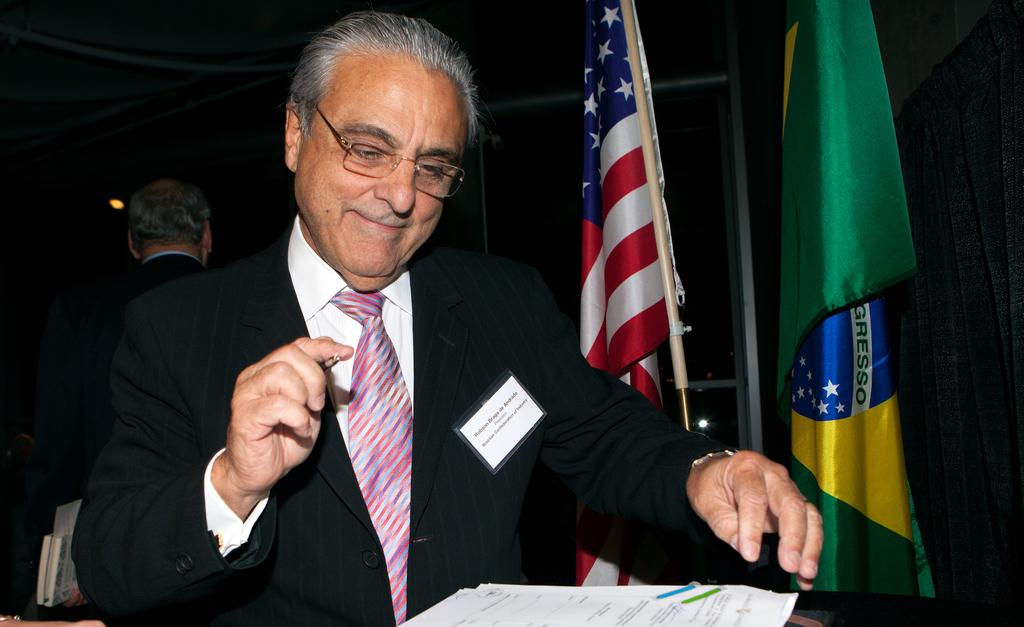What is the person in the foreground of the image doing? The person is holding a pen. What might the person be using the pen for? The person might be using the pen to write or draw on the papers in front of them. What can be seen in the background of the image? There are flags and a man in the background of the image. What might the man in the background be doing? It is difficult to determine what the man in the background is doing without more context, but he could be observing the person in the foreground or engaged in his own activity. What type of orange is being used by the person in the image? There is no orange present in the image; the person is holding a pen. How many pigs are visible in the image? There are no pigs present in the image. 